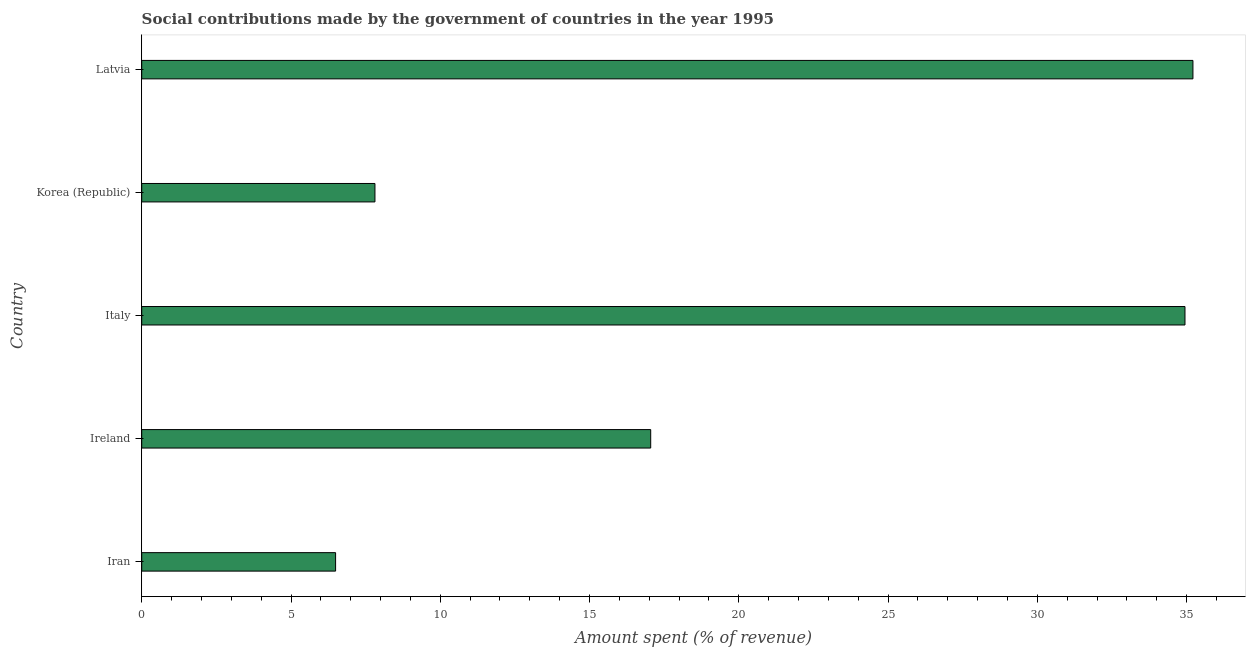Does the graph contain any zero values?
Offer a terse response. No. Does the graph contain grids?
Provide a short and direct response. No. What is the title of the graph?
Your answer should be compact. Social contributions made by the government of countries in the year 1995. What is the label or title of the X-axis?
Give a very brief answer. Amount spent (% of revenue). What is the label or title of the Y-axis?
Your answer should be compact. Country. What is the amount spent in making social contributions in Ireland?
Provide a short and direct response. 17.05. Across all countries, what is the maximum amount spent in making social contributions?
Offer a terse response. 35.21. Across all countries, what is the minimum amount spent in making social contributions?
Your answer should be very brief. 6.49. In which country was the amount spent in making social contributions maximum?
Your answer should be compact. Latvia. In which country was the amount spent in making social contributions minimum?
Offer a terse response. Iran. What is the sum of the amount spent in making social contributions?
Offer a terse response. 101.51. What is the difference between the amount spent in making social contributions in Italy and Korea (Republic)?
Provide a succinct answer. 27.13. What is the average amount spent in making social contributions per country?
Your answer should be compact. 20.3. What is the median amount spent in making social contributions?
Ensure brevity in your answer.  17.05. In how many countries, is the amount spent in making social contributions greater than 19 %?
Your answer should be compact. 2. What is the ratio of the amount spent in making social contributions in Ireland to that in Italy?
Give a very brief answer. 0.49. Is the amount spent in making social contributions in Iran less than that in Latvia?
Give a very brief answer. Yes. What is the difference between the highest and the second highest amount spent in making social contributions?
Offer a very short reply. 0.27. What is the difference between the highest and the lowest amount spent in making social contributions?
Provide a short and direct response. 28.72. In how many countries, is the amount spent in making social contributions greater than the average amount spent in making social contributions taken over all countries?
Make the answer very short. 2. Are all the bars in the graph horizontal?
Ensure brevity in your answer.  Yes. What is the Amount spent (% of revenue) in Iran?
Ensure brevity in your answer.  6.49. What is the Amount spent (% of revenue) in Ireland?
Offer a very short reply. 17.05. What is the Amount spent (% of revenue) of Italy?
Your response must be concise. 34.95. What is the Amount spent (% of revenue) in Korea (Republic)?
Provide a short and direct response. 7.81. What is the Amount spent (% of revenue) in Latvia?
Your answer should be compact. 35.21. What is the difference between the Amount spent (% of revenue) in Iran and Ireland?
Give a very brief answer. -10.55. What is the difference between the Amount spent (% of revenue) in Iran and Italy?
Give a very brief answer. -28.45. What is the difference between the Amount spent (% of revenue) in Iran and Korea (Republic)?
Keep it short and to the point. -1.32. What is the difference between the Amount spent (% of revenue) in Iran and Latvia?
Your answer should be compact. -28.72. What is the difference between the Amount spent (% of revenue) in Ireland and Italy?
Your answer should be compact. -17.9. What is the difference between the Amount spent (% of revenue) in Ireland and Korea (Republic)?
Offer a very short reply. 9.24. What is the difference between the Amount spent (% of revenue) in Ireland and Latvia?
Make the answer very short. -18.16. What is the difference between the Amount spent (% of revenue) in Italy and Korea (Republic)?
Make the answer very short. 27.13. What is the difference between the Amount spent (% of revenue) in Italy and Latvia?
Your answer should be compact. -0.27. What is the difference between the Amount spent (% of revenue) in Korea (Republic) and Latvia?
Offer a very short reply. -27.4. What is the ratio of the Amount spent (% of revenue) in Iran to that in Ireland?
Offer a very short reply. 0.38. What is the ratio of the Amount spent (% of revenue) in Iran to that in Italy?
Offer a very short reply. 0.19. What is the ratio of the Amount spent (% of revenue) in Iran to that in Korea (Republic)?
Your answer should be very brief. 0.83. What is the ratio of the Amount spent (% of revenue) in Iran to that in Latvia?
Provide a succinct answer. 0.18. What is the ratio of the Amount spent (% of revenue) in Ireland to that in Italy?
Offer a very short reply. 0.49. What is the ratio of the Amount spent (% of revenue) in Ireland to that in Korea (Republic)?
Offer a very short reply. 2.18. What is the ratio of the Amount spent (% of revenue) in Ireland to that in Latvia?
Your answer should be very brief. 0.48. What is the ratio of the Amount spent (% of revenue) in Italy to that in Korea (Republic)?
Make the answer very short. 4.47. What is the ratio of the Amount spent (% of revenue) in Korea (Republic) to that in Latvia?
Provide a succinct answer. 0.22. 